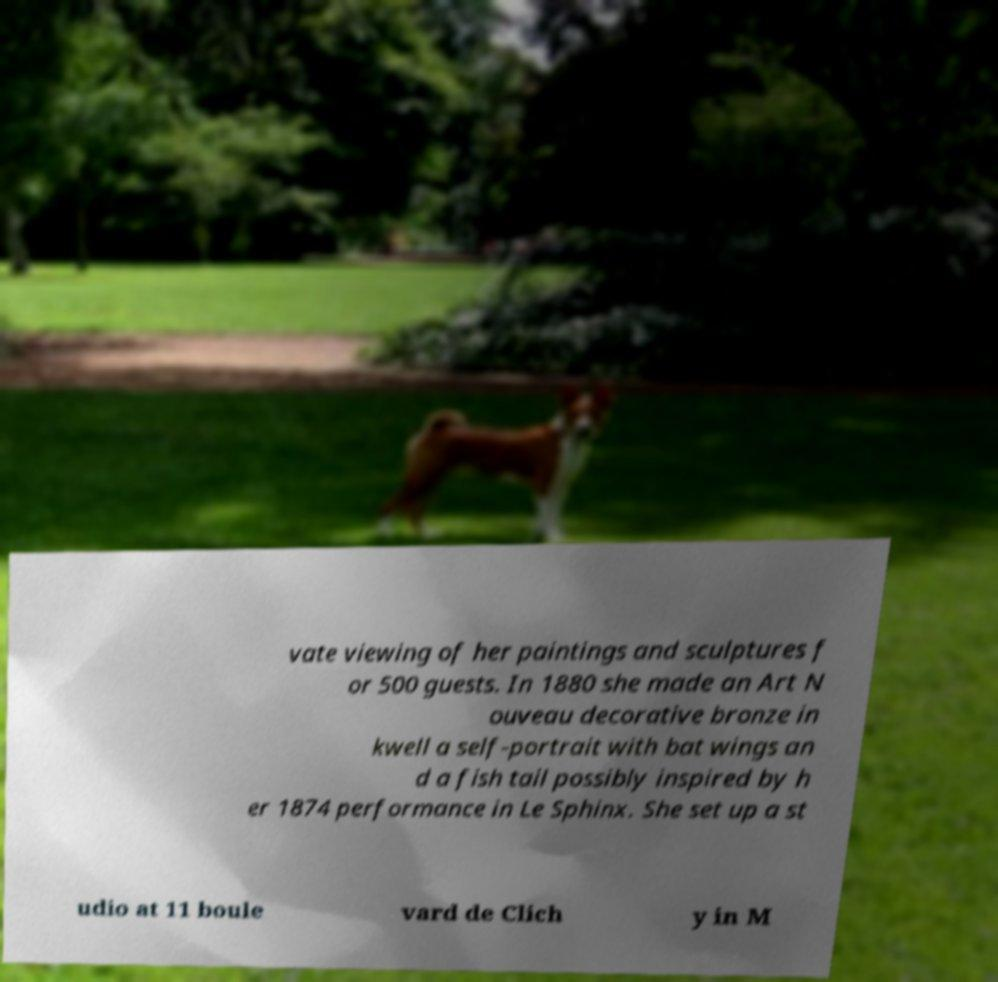For documentation purposes, I need the text within this image transcribed. Could you provide that? vate viewing of her paintings and sculptures f or 500 guests. In 1880 she made an Art N ouveau decorative bronze in kwell a self-portrait with bat wings an d a fish tail possibly inspired by h er 1874 performance in Le Sphinx. She set up a st udio at 11 boule vard de Clich y in M 